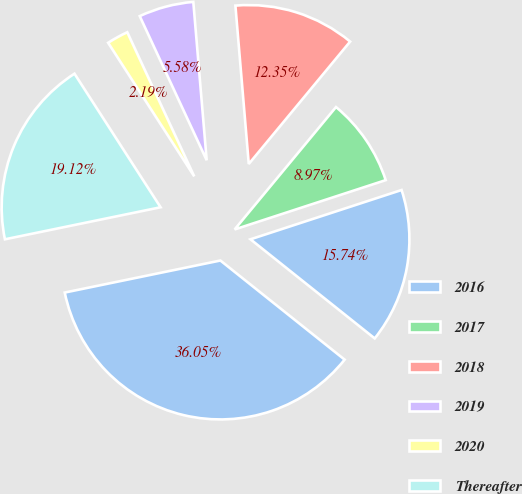Convert chart to OTSL. <chart><loc_0><loc_0><loc_500><loc_500><pie_chart><fcel>2016<fcel>2017<fcel>2018<fcel>2019<fcel>2020<fcel>Thereafter<fcel>Total<nl><fcel>15.74%<fcel>8.97%<fcel>12.35%<fcel>5.58%<fcel>2.19%<fcel>19.12%<fcel>36.05%<nl></chart> 